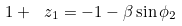<formula> <loc_0><loc_0><loc_500><loc_500>1 + \ z _ { 1 } = - 1 - \beta \sin \phi _ { 2 }</formula> 